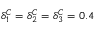Convert formula to latex. <formula><loc_0><loc_0><loc_500><loc_500>\delta _ { 1 } ^ { C } = \delta _ { 2 } ^ { C } = \delta _ { 3 } ^ { C } = 0 . 4</formula> 